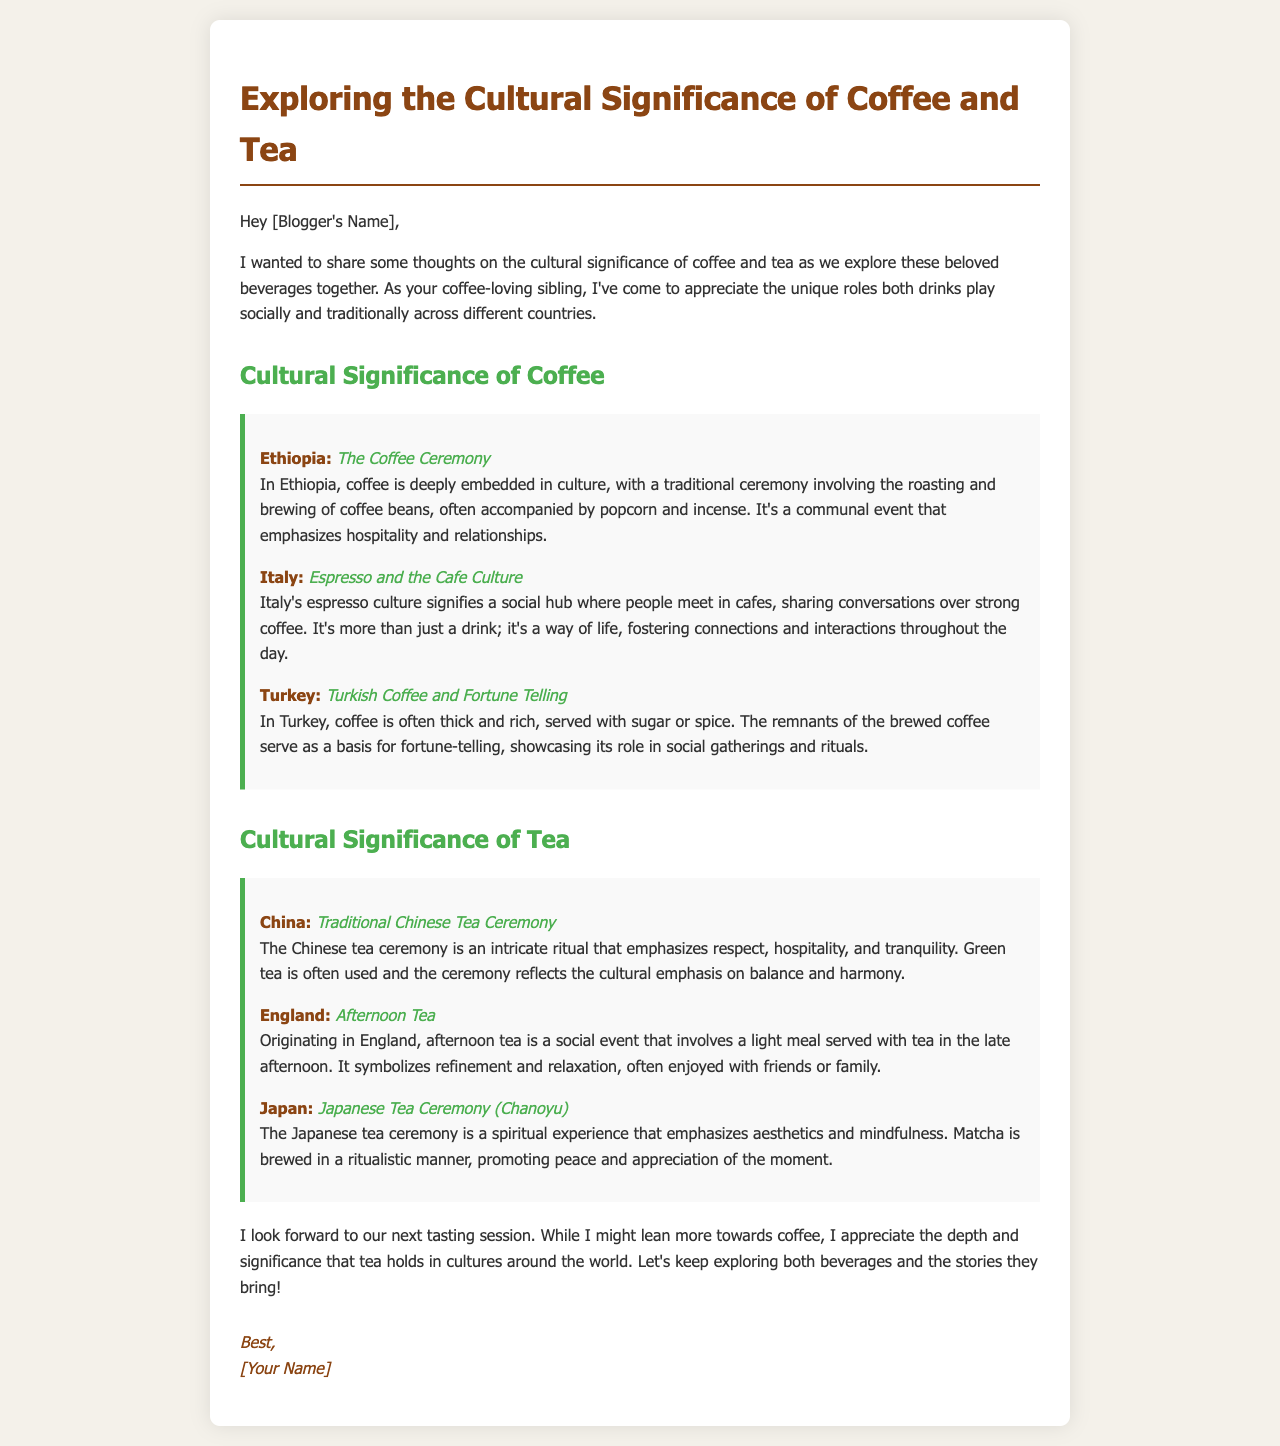What is the title of the document? The title of the document reflects its focus on the cultural aspects of beverages, specifically coffee and tea.
Answer: Exploring the Cultural Significance of Coffee and Tea What country is known for the Coffee Ceremony? The document specifically names Ethiopia as the country with a traditional coffee ceremony that emphasizes social interactions and hospitality.
Answer: Ethiopia What social event is associated with England? The document identifies a specific tea-related event in England that represents refinement and socializing.
Answer: Afternoon Tea Which beverage is often served in Japanese tea ceremonies? The document mentions a specific type of tea used in Japanese ceremonies that highlights mindfulness and aesthetics.
Answer: Matcha In which country does espresso culture prevail? Italy is highlighted in the document as the country where espresso culture plays a significant role in social connections.
Answer: Italy What kind of fortune-telling is associated with Turkish coffee? The document mentions a unique cultural practice involving coffee remnants, linking it to social rituals in Turkey.
Answer: Fortune Telling What beverage is often used in the Chinese tea ceremony? The document specifies the type of tea that is predominantly used in China’s traditional tea ceremonies.
Answer: Green tea How does the Japanese tea ceremony promote appreciation? The document emphasizes that the Japanese tea ceremony is more than just preparing tea, but a ritual promoting a deeper understanding and mindfulness.
Answer: Mindfulness What is the overall theme of the document? The document encapsulates a comparison of cultural practices surrounding coffee and tea, focusing on their roles in society.
Answer: Cultural significance of coffee and tea 